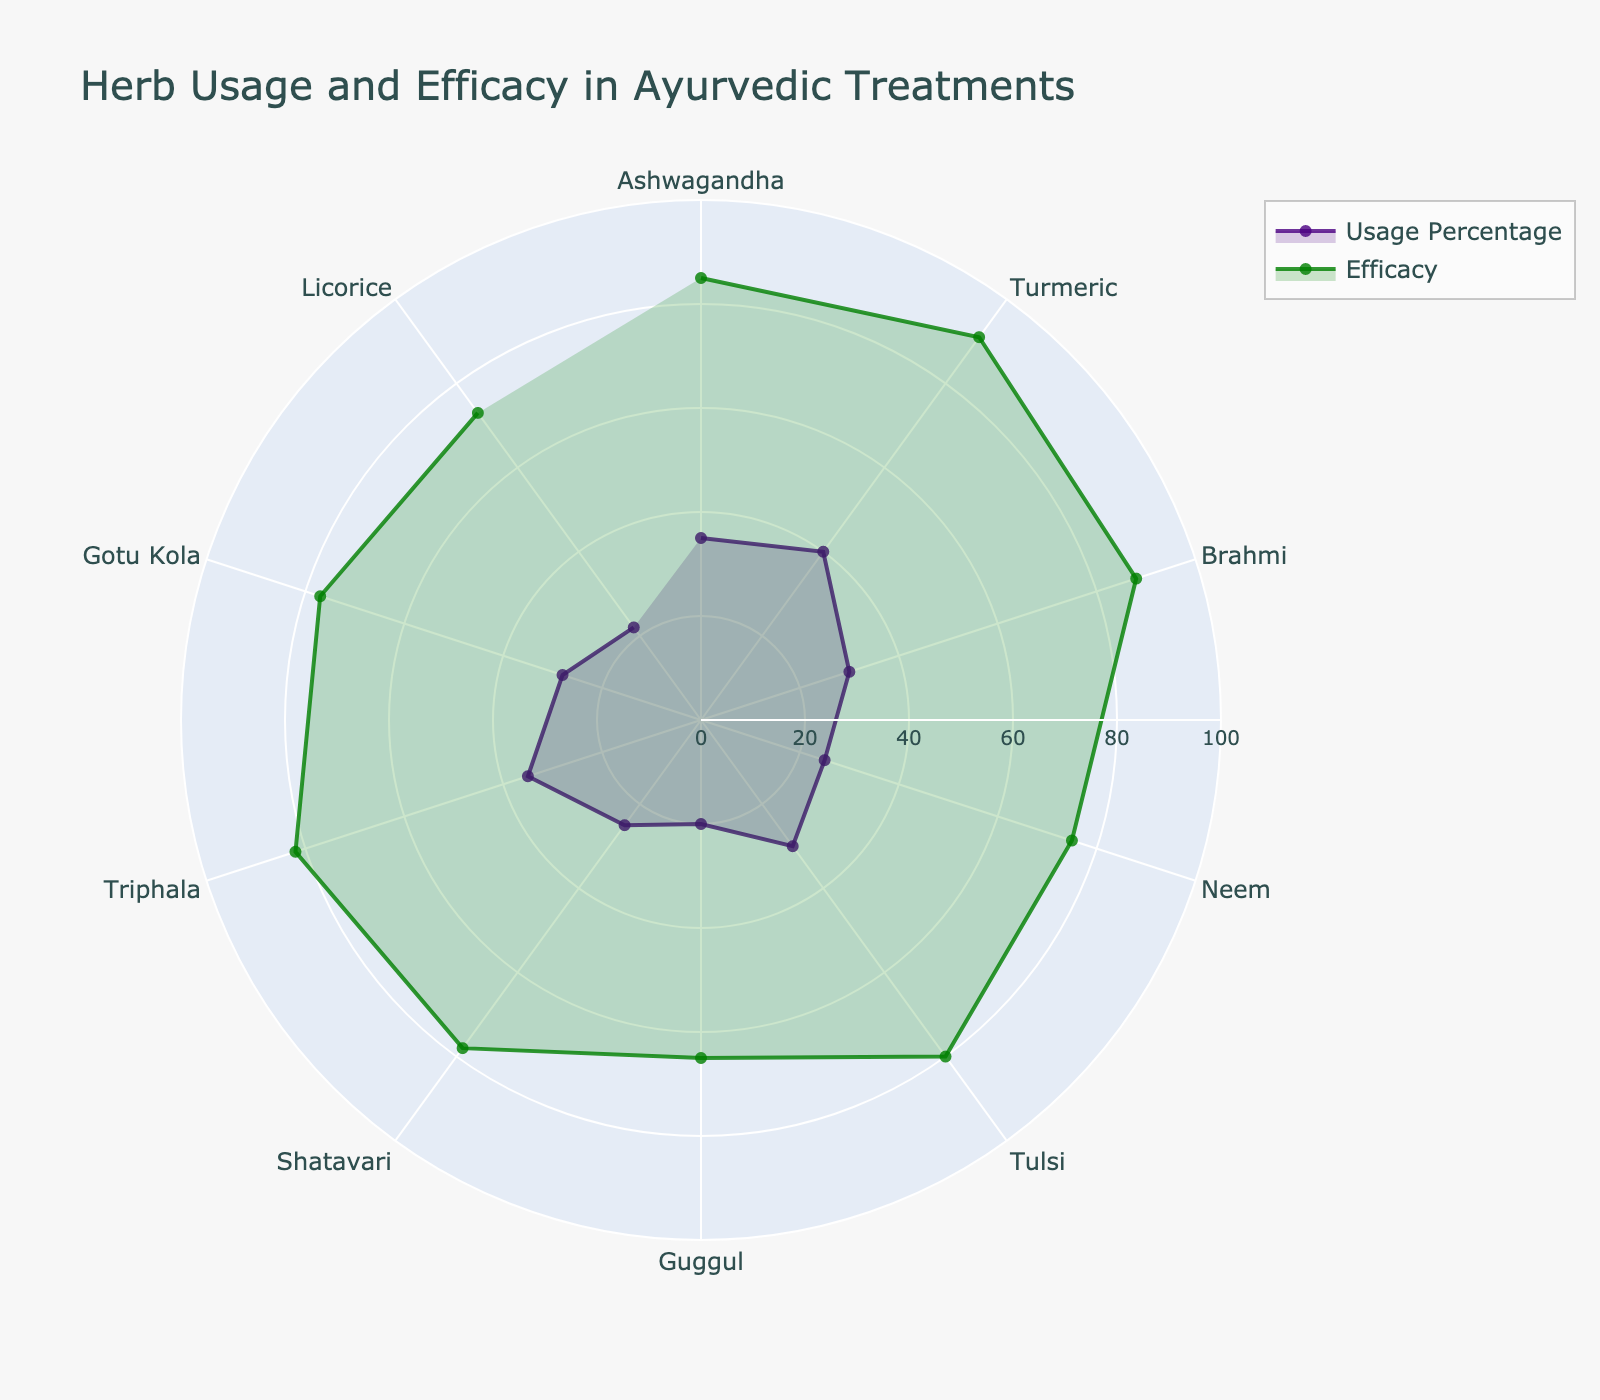Which herb has the highest usage percentage? Look at the purple area representing usage percentages and identify the herb with the highest value. Turmeric has the highest usage percentage at 40.
Answer: Turmeric What is the average efficacy rating across all herbs? Add up all the efficacy percentages and divide by the number of herbs. The total efficacy is (85 + 91 + 88 + 75 + 80 + 65 + 78 + 82 + 77 + 73) = 794. Divide by 10.
Answer: 79.4 Which herb exhibits the lowest efficacy? Compare the green area representing efficacy percentages and find the smallest value. Guggul has the lowest efficacy at 65.
Answer: Guggul How does the usage percentage of Ashwagandha compare to its efficacy? Find both the usage percentage and efficacy for Ashwagandha and compare them. Ashwagandha has a usage percentage of 35 and an efficacy of 85, so the efficacy is higher.
Answer: Efficacy is higher Is there any herb where the efficacy is less than its usage percentage? Compare the efficacy and usage percentages for each herb. Only Guggul has lower efficacy (65) than its usage percentage (20).
Answer: Yes, Guggul What's the combined usage percentage for herbs used in Cognitive Function and Mental Clarity? Add the usage percentages for Brahmi (30) and Gotu Kola (28). 30 + 28 = 58.
Answer: 58 Which herb has the closest usage percentage to Neem? Look at the usage percentages and find the herb closest to Neem's usage percentage of 25. Shatavari also has a usage percentage of 25.
Answer: Shatavari What is the difference in efficacy between the herb with the highest efficacy and the herb with the lowest efficacy? Identify the highest efficacy (Turmeric at 91) and the lowest efficacy (Guggul at 65) and find the difference: 91 - 65 = 26.
Answer: 26 Compare the efficacy of Brahmi to that of Gotu Kola. Which is higher? Look at the efficacy percentages for Brahmi (88) and Gotu Kola (77). Brahmi has higher efficacy.
Answer: Brahmi 